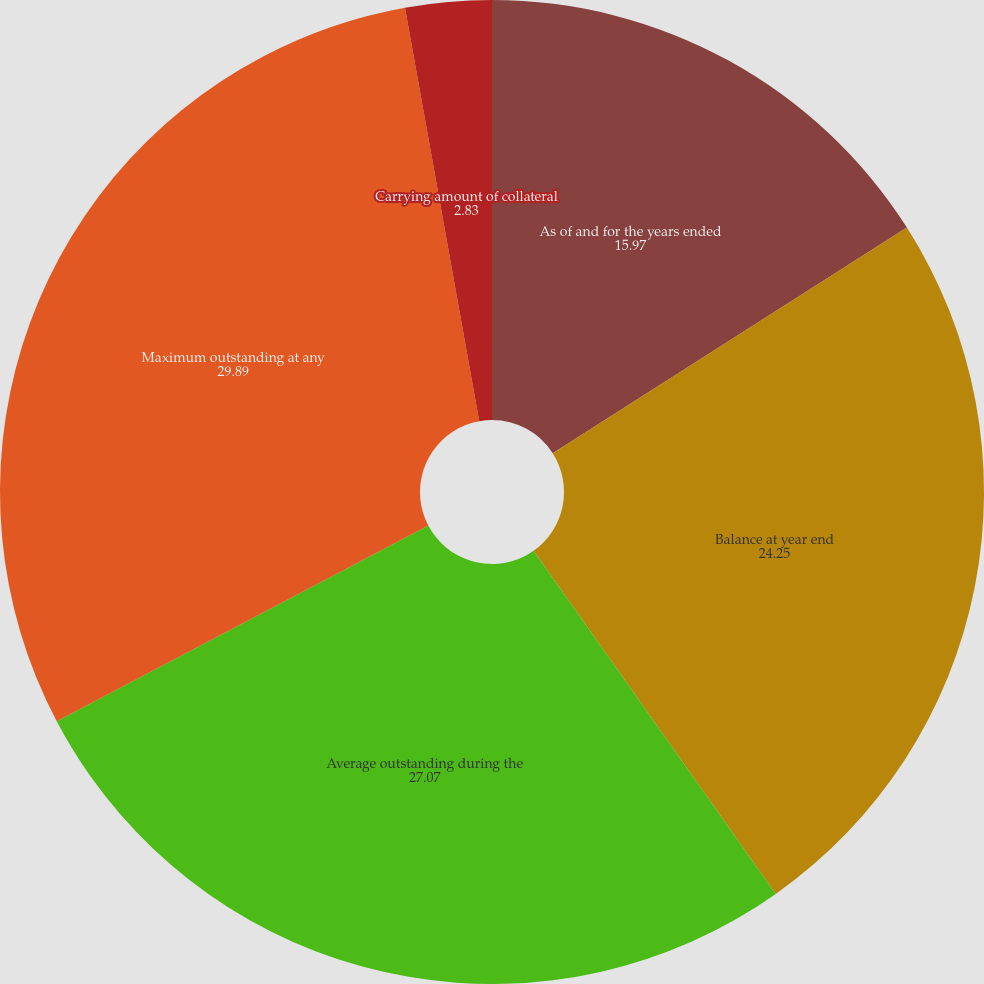Convert chart. <chart><loc_0><loc_0><loc_500><loc_500><pie_chart><fcel>As of and for the years ended<fcel>Balance at year end<fcel>Average outstanding during the<fcel>Maximum outstanding at any<fcel>Average interest rate during<fcel>Carrying amount of collateral<nl><fcel>15.97%<fcel>24.25%<fcel>27.07%<fcel>29.89%<fcel>0.0%<fcel>2.83%<nl></chart> 